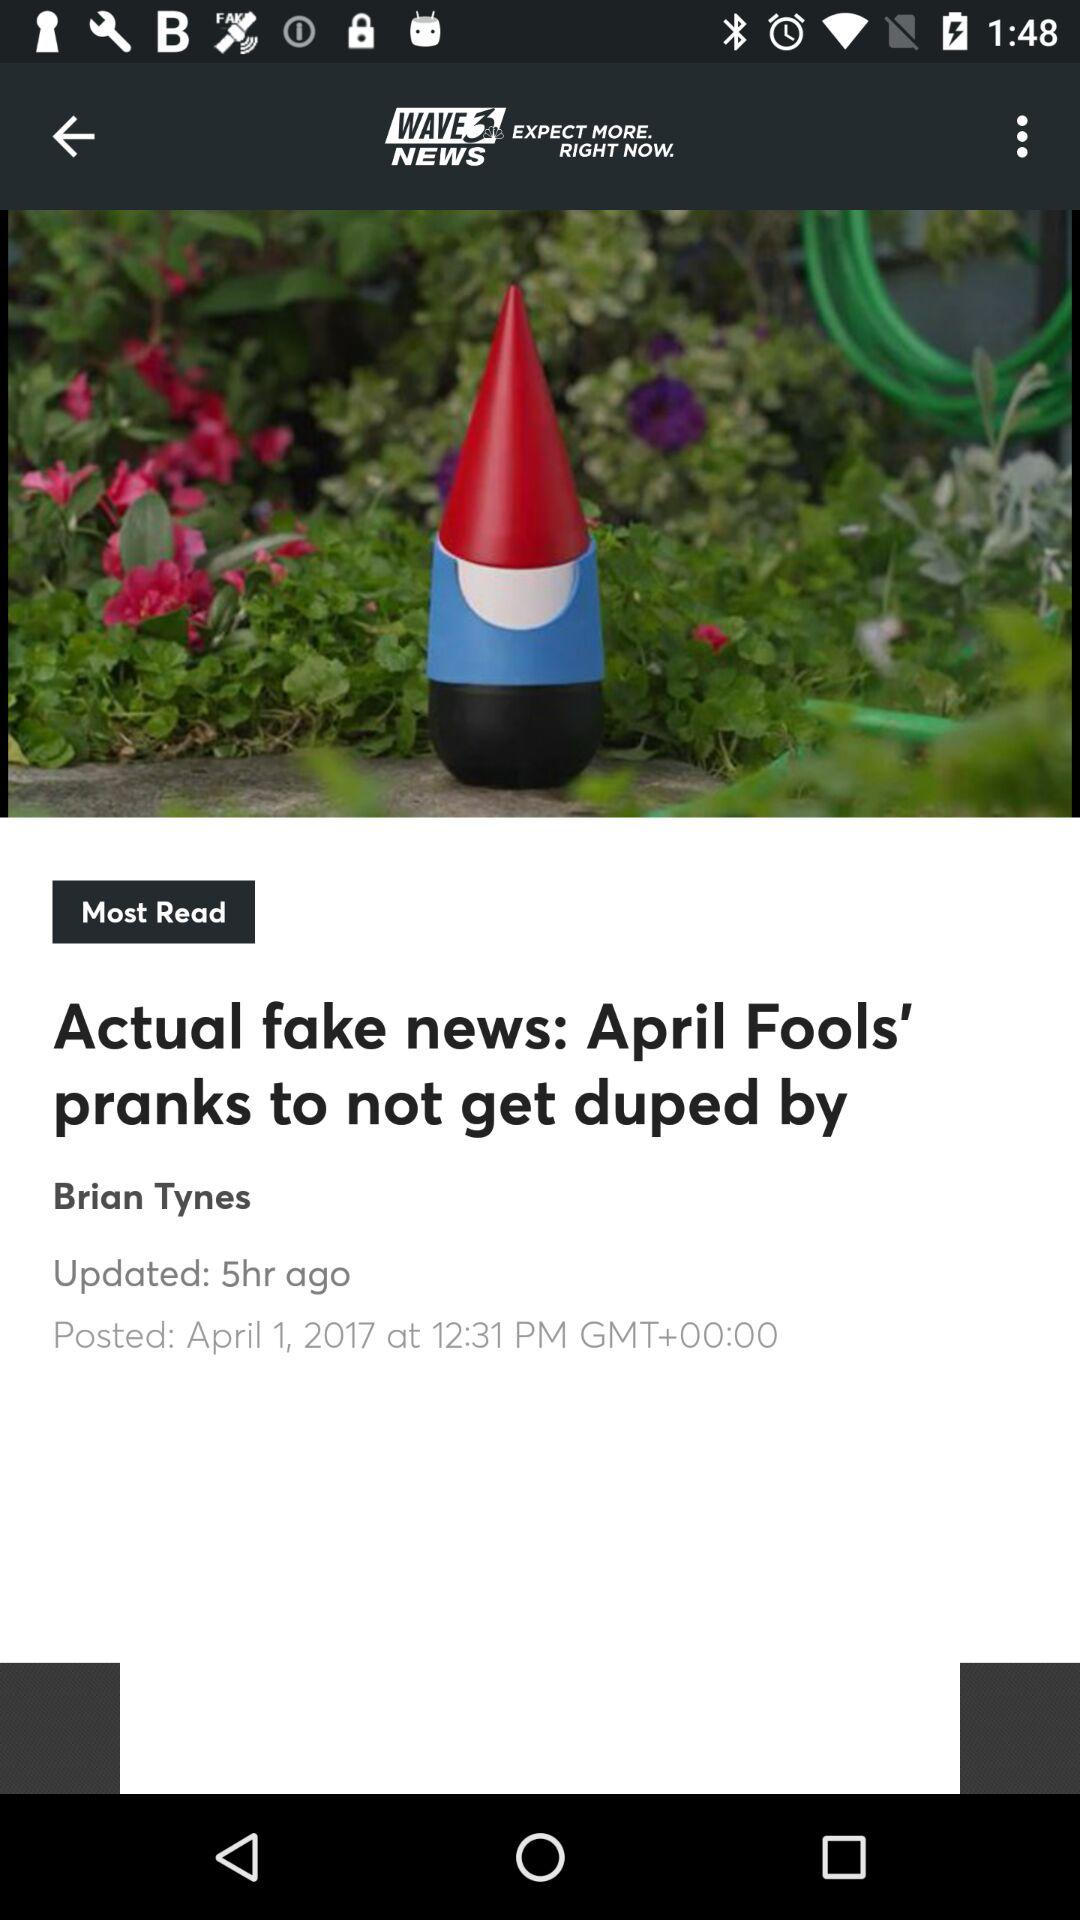What is the headline of the news? The headline of the news is "Actual fake news: April Fools' pranks to not get duped by". 